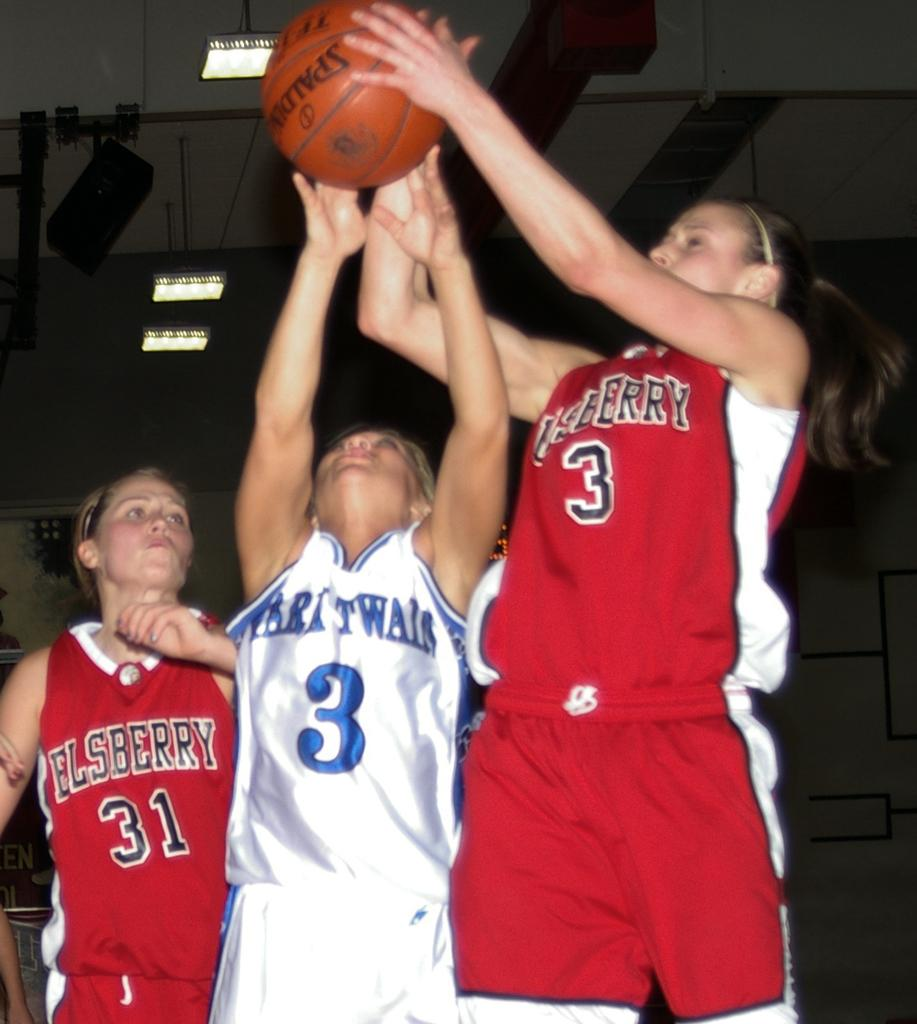<image>
Present a compact description of the photo's key features. a few players and one with the number 3 on their jersey 